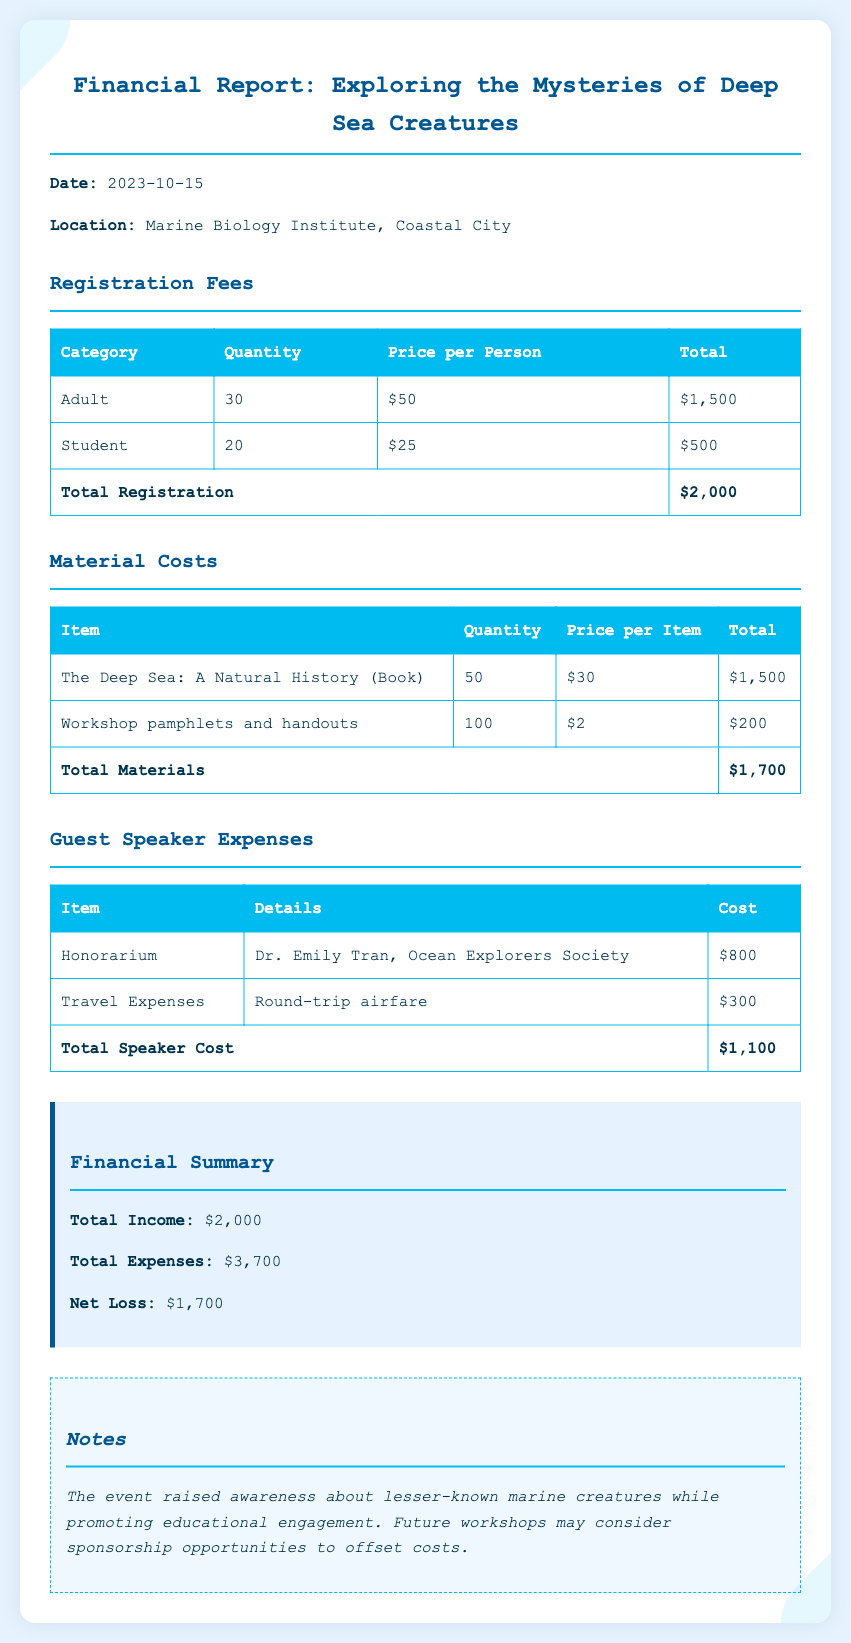what is the total registration amount? The total registration amount is shown in the Registration Fees section of the document, which lists $2,000.
Answer: $2,000 who gave the guest speaker presentation? The guest speaker presentation was given by Dr. Emily Tran from the Ocean Explorers Society.
Answer: Dr. Emily Tran what is the date of the financial report? The date of the financial report is specified at the beginning of the document as 2023-10-15.
Answer: 2023-10-15 what are the total material costs? The total material costs are found in the Material Costs section, which totals $1,700.
Answer: $1,700 how much was the honorarium for the guest speaker? The honorarium for the guest speaker is listed as $800 under Guest Speaker Expenses.
Answer: $800 is there a net income or loss reported? The document indicates a net loss of $1,700 in the Financial Summary section.
Answer: $1,700 what was the cost of the workshop pamphlets? The cost of the workshop pamphlets is stated as $200 in the Material Costs table.
Answer: $200 how many adult participants registered for the workshop? The number of adult participants registered is mentioned in the Registration Fees section as 30.
Answer: 30 what is the location of the event? The location of the event is specified as the Marine Biology Institute, Coastal City.
Answer: Marine Biology Institute, Coastal City 